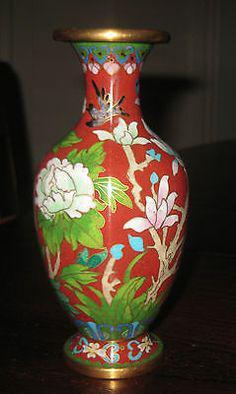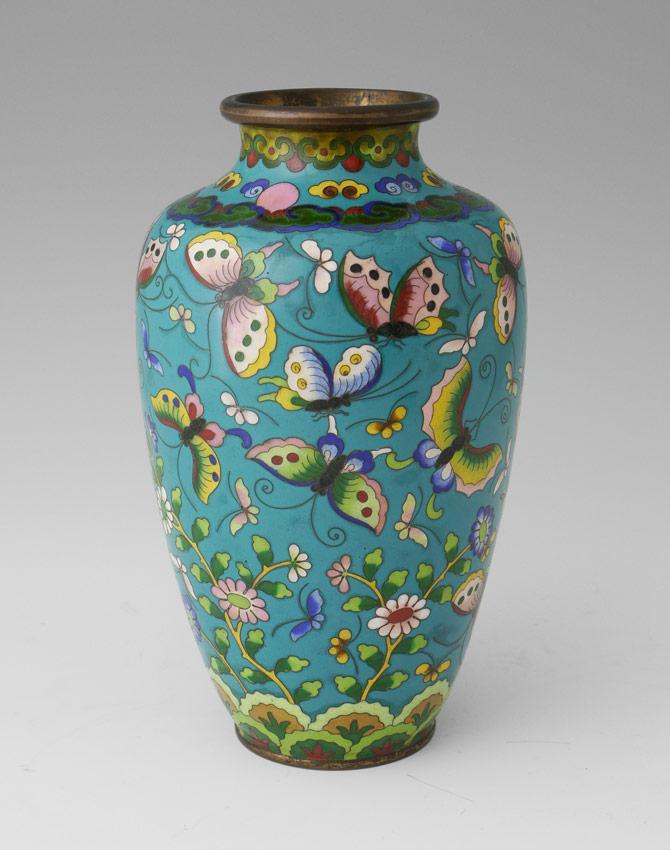The first image is the image on the left, the second image is the image on the right. Evaluate the accuracy of this statement regarding the images: "One of the vases is predominantly white, while the other is mostly patterned.". Is it true? Answer yes or no. No. The first image is the image on the left, the second image is the image on the right. Given the left and right images, does the statement "One vase features a sky-blue background decorated with flowers and flying creatures." hold true? Answer yes or no. Yes. 